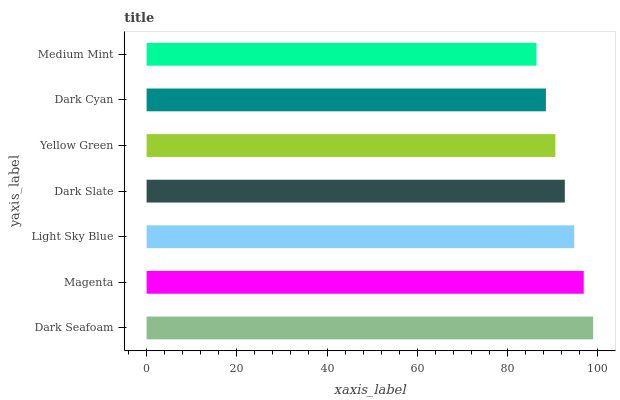Is Medium Mint the minimum?
Answer yes or no. Yes. Is Dark Seafoam the maximum?
Answer yes or no. Yes. Is Magenta the minimum?
Answer yes or no. No. Is Magenta the maximum?
Answer yes or no. No. Is Dark Seafoam greater than Magenta?
Answer yes or no. Yes. Is Magenta less than Dark Seafoam?
Answer yes or no. Yes. Is Magenta greater than Dark Seafoam?
Answer yes or no. No. Is Dark Seafoam less than Magenta?
Answer yes or no. No. Is Dark Slate the high median?
Answer yes or no. Yes. Is Dark Slate the low median?
Answer yes or no. Yes. Is Dark Cyan the high median?
Answer yes or no. No. Is Medium Mint the low median?
Answer yes or no. No. 